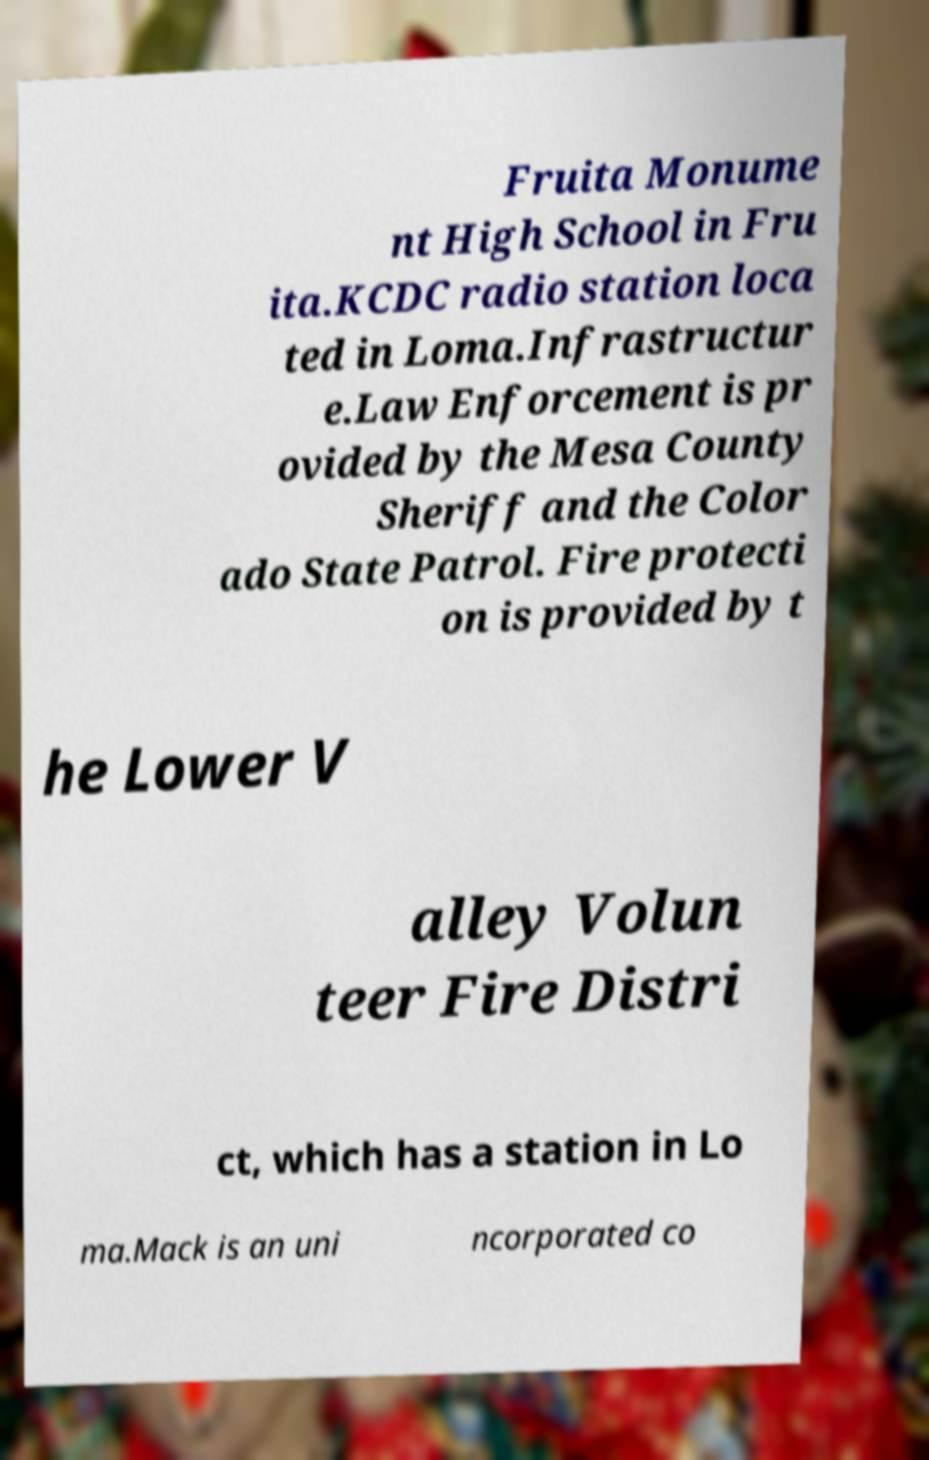Please identify and transcribe the text found in this image. Fruita Monume nt High School in Fru ita.KCDC radio station loca ted in Loma.Infrastructur e.Law Enforcement is pr ovided by the Mesa County Sheriff and the Color ado State Patrol. Fire protecti on is provided by t he Lower V alley Volun teer Fire Distri ct, which has a station in Lo ma.Mack is an uni ncorporated co 